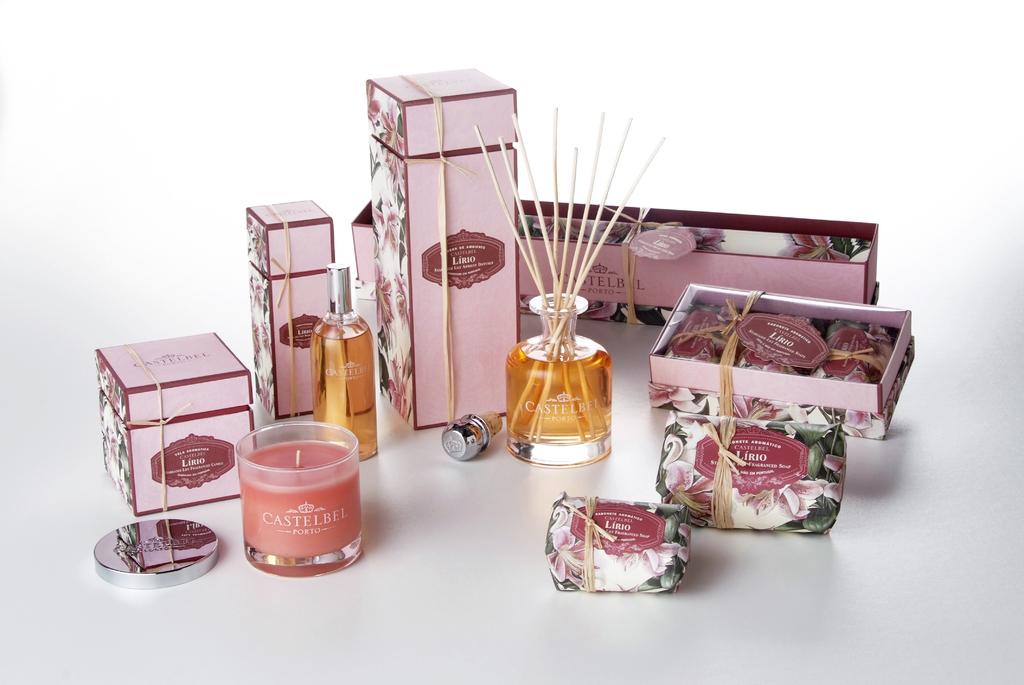Are there soaps and perfume in this collection?
Provide a succinct answer. Answering does not require reading text in the image. 